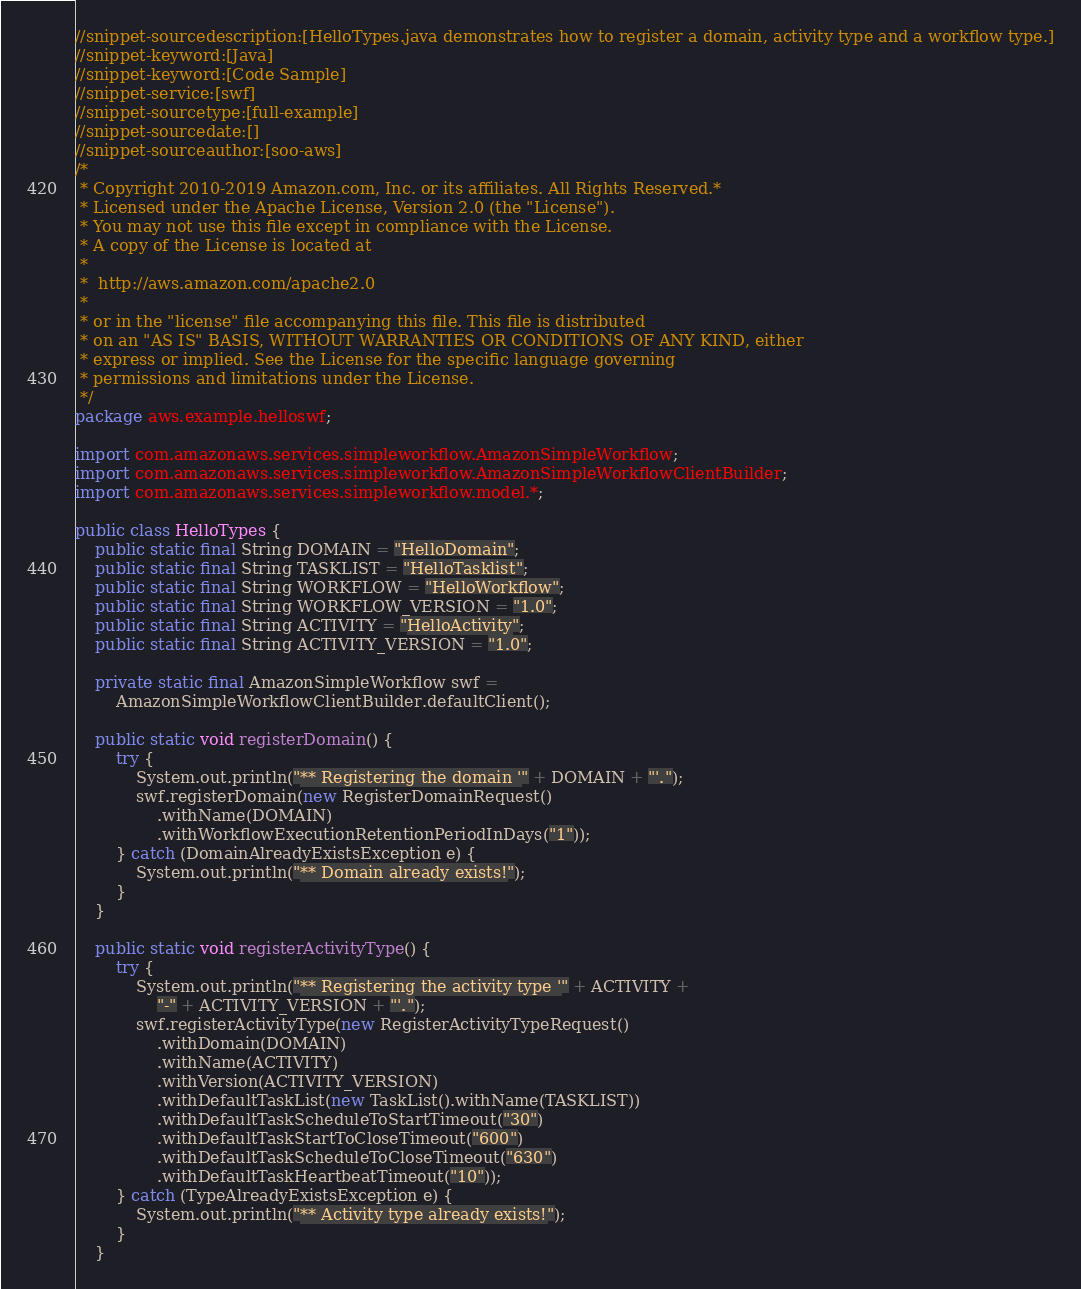Convert code to text. <code><loc_0><loc_0><loc_500><loc_500><_Java_>//snippet-sourcedescription:[HelloTypes.java demonstrates how to register a domain, activity type and a workflow type.]
//snippet-keyword:[Java]
//snippet-keyword:[Code Sample]
//snippet-service:[swf]
//snippet-sourcetype:[full-example]
//snippet-sourcedate:[]
//snippet-sourceauthor:[soo-aws]
/*
 * Copyright 2010-2019 Amazon.com, Inc. or its affiliates. All Rights Reserved.*
 * Licensed under the Apache License, Version 2.0 (the "License").
 * You may not use this file except in compliance with the License.
 * A copy of the License is located at
 *
 *  http://aws.amazon.com/apache2.0
 *
 * or in the "license" file accompanying this file. This file is distributed
 * on an "AS IS" BASIS, WITHOUT WARRANTIES OR CONDITIONS OF ANY KIND, either
 * express or implied. See the License for the specific language governing
 * permissions and limitations under the License.
 */
package aws.example.helloswf;

import com.amazonaws.services.simpleworkflow.AmazonSimpleWorkflow;
import com.amazonaws.services.simpleworkflow.AmazonSimpleWorkflowClientBuilder;
import com.amazonaws.services.simpleworkflow.model.*;

public class HelloTypes {
    public static final String DOMAIN = "HelloDomain";
    public static final String TASKLIST = "HelloTasklist";
    public static final String WORKFLOW = "HelloWorkflow";
    public static final String WORKFLOW_VERSION = "1.0";
    public static final String ACTIVITY = "HelloActivity";
    public static final String ACTIVITY_VERSION = "1.0";

    private static final AmazonSimpleWorkflow swf =
        AmazonSimpleWorkflowClientBuilder.defaultClient();

    public static void registerDomain() {
        try {
            System.out.println("** Registering the domain '" + DOMAIN + "'.");
            swf.registerDomain(new RegisterDomainRequest()
                .withName(DOMAIN)
                .withWorkflowExecutionRetentionPeriodInDays("1"));
        } catch (DomainAlreadyExistsException e) {
            System.out.println("** Domain already exists!");
        }
    }

    public static void registerActivityType() {
        try {
            System.out.println("** Registering the activity type '" + ACTIVITY +
                "-" + ACTIVITY_VERSION + "'.");
            swf.registerActivityType(new RegisterActivityTypeRequest()
                .withDomain(DOMAIN)
                .withName(ACTIVITY)
                .withVersion(ACTIVITY_VERSION)
                .withDefaultTaskList(new TaskList().withName(TASKLIST))
                .withDefaultTaskScheduleToStartTimeout("30")
                .withDefaultTaskStartToCloseTimeout("600")
                .withDefaultTaskScheduleToCloseTimeout("630")
                .withDefaultTaskHeartbeatTimeout("10"));
        } catch (TypeAlreadyExistsException e) {
            System.out.println("** Activity type already exists!");
        }
    }
</code> 